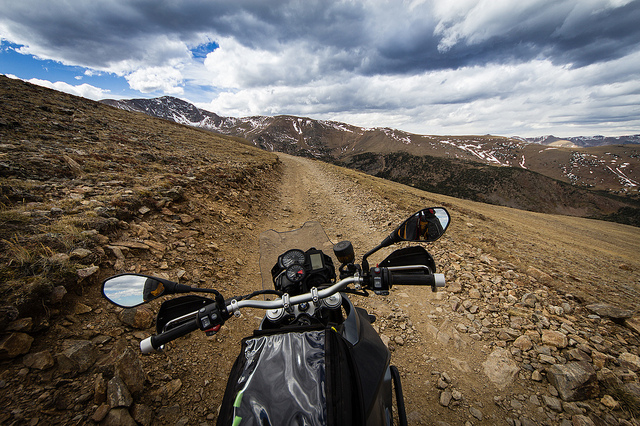What type of weather conditions might a traveler encounter in this area? Travelers might face a variety of weather conditions, including sudden changes in temperature, wind, and the possibility of storms, as suggested by the clouds indicating instability in the weather pattern. 